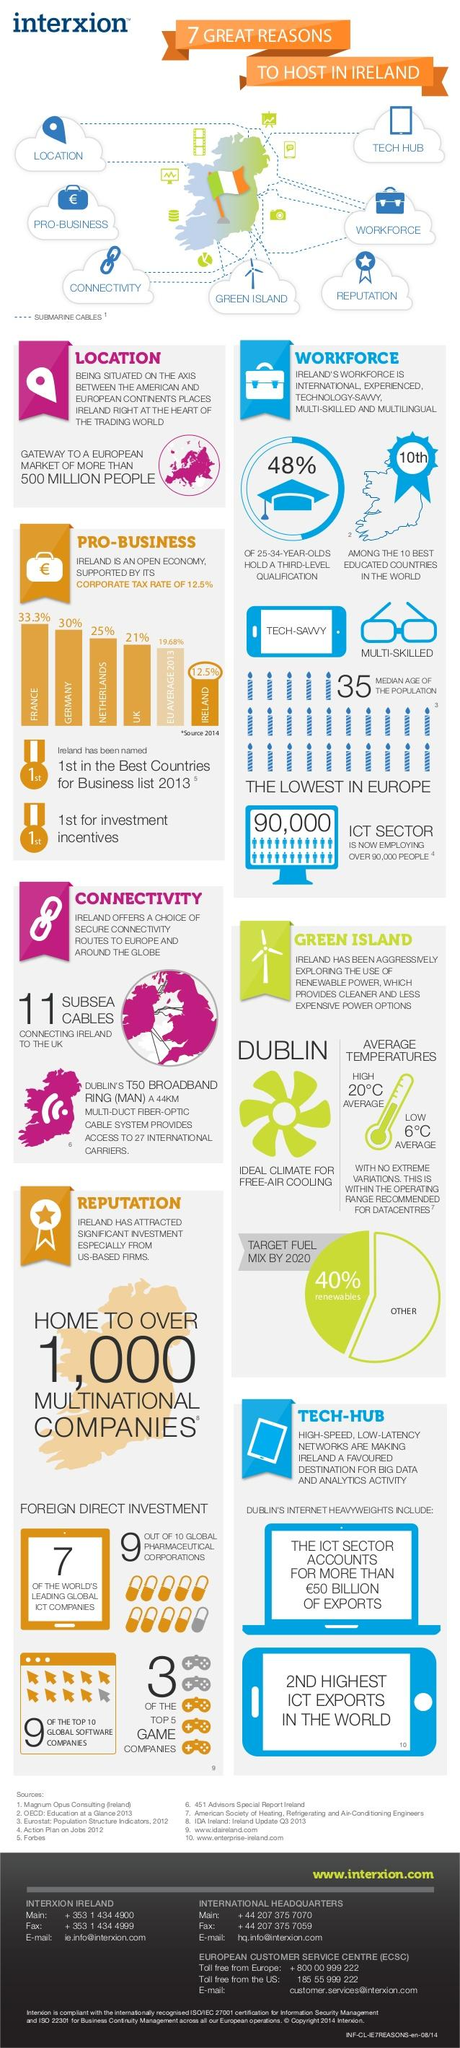Mention a couple of crucial points in this snapshot. In 2013, the average corporate tax rate of EU member states was 19.68%. In 2014, the corporate tax rate in Germany was 30%. The Netherlands has a corporate tax rate of 25%, making it the country with the lowest tax rate among the options of France, Netherlands, and UK. 